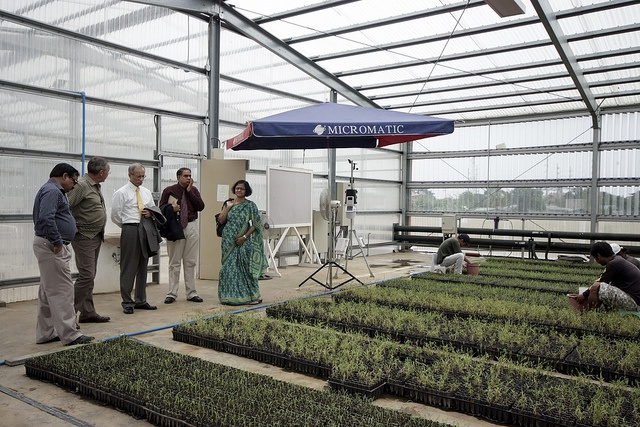Describe the objects in this image and their specific colors. I can see people in lightgray, gray, black, and darkgray tones, umbrella in lightgray, darkgray, navy, and gray tones, people in lightgray, black, darkgray, and gray tones, people in lightgray, gray, black, and teal tones, and people in lightgray, black, and gray tones in this image. 